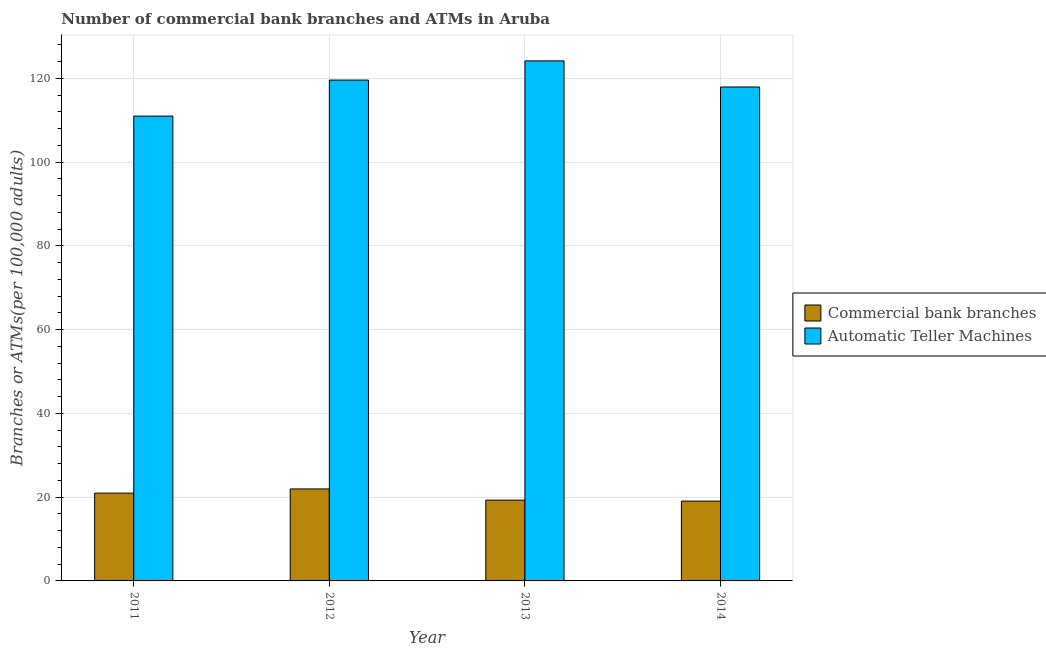How many groups of bars are there?
Keep it short and to the point. 4. How many bars are there on the 3rd tick from the right?
Offer a terse response. 2. What is the number of commercal bank branches in 2012?
Your response must be concise. 21.96. Across all years, what is the maximum number of atms?
Provide a short and direct response. 124.15. Across all years, what is the minimum number of commercal bank branches?
Provide a succinct answer. 19.06. In which year was the number of atms maximum?
Your response must be concise. 2013. In which year was the number of atms minimum?
Provide a succinct answer. 2011. What is the total number of atms in the graph?
Make the answer very short. 472.61. What is the difference between the number of atms in 2011 and that in 2013?
Make the answer very short. -13.18. What is the difference between the number of atms in 2012 and the number of commercal bank branches in 2013?
Give a very brief answer. -4.58. What is the average number of atms per year?
Your answer should be very brief. 118.15. What is the ratio of the number of commercal bank branches in 2011 to that in 2013?
Keep it short and to the point. 1.09. Is the difference between the number of atms in 2012 and 2013 greater than the difference between the number of commercal bank branches in 2012 and 2013?
Offer a very short reply. No. What is the difference between the highest and the second highest number of commercal bank branches?
Provide a succinct answer. 1. What is the difference between the highest and the lowest number of commercal bank branches?
Offer a terse response. 2.9. In how many years, is the number of commercal bank branches greater than the average number of commercal bank branches taken over all years?
Offer a very short reply. 2. What does the 2nd bar from the left in 2011 represents?
Your answer should be very brief. Automatic Teller Machines. What does the 2nd bar from the right in 2011 represents?
Give a very brief answer. Commercial bank branches. How many years are there in the graph?
Offer a terse response. 4. What is the difference between two consecutive major ticks on the Y-axis?
Ensure brevity in your answer.  20. Does the graph contain any zero values?
Provide a succinct answer. No. Does the graph contain grids?
Provide a short and direct response. Yes. Where does the legend appear in the graph?
Provide a short and direct response. Center right. How many legend labels are there?
Offer a terse response. 2. How are the legend labels stacked?
Make the answer very short. Vertical. What is the title of the graph?
Offer a terse response. Number of commercial bank branches and ATMs in Aruba. What is the label or title of the Y-axis?
Provide a succinct answer. Branches or ATMs(per 100,0 adults). What is the Branches or ATMs(per 100,000 adults) in Commercial bank branches in 2011?
Provide a short and direct response. 20.96. What is the Branches or ATMs(per 100,000 adults) of Automatic Teller Machines in 2011?
Make the answer very short. 110.97. What is the Branches or ATMs(per 100,000 adults) in Commercial bank branches in 2012?
Provide a short and direct response. 21.96. What is the Branches or ATMs(per 100,000 adults) in Automatic Teller Machines in 2012?
Your response must be concise. 119.57. What is the Branches or ATMs(per 100,000 adults) in Commercial bank branches in 2013?
Your answer should be compact. 19.29. What is the Branches or ATMs(per 100,000 adults) in Automatic Teller Machines in 2013?
Provide a succinct answer. 124.15. What is the Branches or ATMs(per 100,000 adults) in Commercial bank branches in 2014?
Give a very brief answer. 19.06. What is the Branches or ATMs(per 100,000 adults) in Automatic Teller Machines in 2014?
Offer a very short reply. 117.92. Across all years, what is the maximum Branches or ATMs(per 100,000 adults) of Commercial bank branches?
Provide a succinct answer. 21.96. Across all years, what is the maximum Branches or ATMs(per 100,000 adults) of Automatic Teller Machines?
Make the answer very short. 124.15. Across all years, what is the minimum Branches or ATMs(per 100,000 adults) of Commercial bank branches?
Your response must be concise. 19.06. Across all years, what is the minimum Branches or ATMs(per 100,000 adults) of Automatic Teller Machines?
Ensure brevity in your answer.  110.97. What is the total Branches or ATMs(per 100,000 adults) in Commercial bank branches in the graph?
Offer a terse response. 81.27. What is the total Branches or ATMs(per 100,000 adults) in Automatic Teller Machines in the graph?
Your answer should be very brief. 472.61. What is the difference between the Branches or ATMs(per 100,000 adults) of Commercial bank branches in 2011 and that in 2012?
Your answer should be compact. -1. What is the difference between the Branches or ATMs(per 100,000 adults) in Automatic Teller Machines in 2011 and that in 2012?
Provide a short and direct response. -8.6. What is the difference between the Branches or ATMs(per 100,000 adults) of Commercial bank branches in 2011 and that in 2013?
Provide a short and direct response. 1.68. What is the difference between the Branches or ATMs(per 100,000 adults) of Automatic Teller Machines in 2011 and that in 2013?
Offer a terse response. -13.18. What is the difference between the Branches or ATMs(per 100,000 adults) in Commercial bank branches in 2011 and that in 2014?
Keep it short and to the point. 1.9. What is the difference between the Branches or ATMs(per 100,000 adults) in Automatic Teller Machines in 2011 and that in 2014?
Make the answer very short. -6.95. What is the difference between the Branches or ATMs(per 100,000 adults) of Commercial bank branches in 2012 and that in 2013?
Offer a very short reply. 2.68. What is the difference between the Branches or ATMs(per 100,000 adults) of Automatic Teller Machines in 2012 and that in 2013?
Provide a succinct answer. -4.58. What is the difference between the Branches or ATMs(per 100,000 adults) of Commercial bank branches in 2012 and that in 2014?
Offer a very short reply. 2.9. What is the difference between the Branches or ATMs(per 100,000 adults) of Automatic Teller Machines in 2012 and that in 2014?
Your answer should be compact. 1.65. What is the difference between the Branches or ATMs(per 100,000 adults) of Commercial bank branches in 2013 and that in 2014?
Provide a short and direct response. 0.23. What is the difference between the Branches or ATMs(per 100,000 adults) of Automatic Teller Machines in 2013 and that in 2014?
Give a very brief answer. 6.24. What is the difference between the Branches or ATMs(per 100,000 adults) of Commercial bank branches in 2011 and the Branches or ATMs(per 100,000 adults) of Automatic Teller Machines in 2012?
Offer a very short reply. -98.61. What is the difference between the Branches or ATMs(per 100,000 adults) of Commercial bank branches in 2011 and the Branches or ATMs(per 100,000 adults) of Automatic Teller Machines in 2013?
Give a very brief answer. -103.19. What is the difference between the Branches or ATMs(per 100,000 adults) in Commercial bank branches in 2011 and the Branches or ATMs(per 100,000 adults) in Automatic Teller Machines in 2014?
Your answer should be very brief. -96.96. What is the difference between the Branches or ATMs(per 100,000 adults) of Commercial bank branches in 2012 and the Branches or ATMs(per 100,000 adults) of Automatic Teller Machines in 2013?
Your answer should be very brief. -102.19. What is the difference between the Branches or ATMs(per 100,000 adults) in Commercial bank branches in 2012 and the Branches or ATMs(per 100,000 adults) in Automatic Teller Machines in 2014?
Keep it short and to the point. -95.96. What is the difference between the Branches or ATMs(per 100,000 adults) of Commercial bank branches in 2013 and the Branches or ATMs(per 100,000 adults) of Automatic Teller Machines in 2014?
Your answer should be compact. -98.63. What is the average Branches or ATMs(per 100,000 adults) in Commercial bank branches per year?
Your response must be concise. 20.32. What is the average Branches or ATMs(per 100,000 adults) in Automatic Teller Machines per year?
Provide a short and direct response. 118.15. In the year 2011, what is the difference between the Branches or ATMs(per 100,000 adults) of Commercial bank branches and Branches or ATMs(per 100,000 adults) of Automatic Teller Machines?
Your response must be concise. -90.01. In the year 2012, what is the difference between the Branches or ATMs(per 100,000 adults) of Commercial bank branches and Branches or ATMs(per 100,000 adults) of Automatic Teller Machines?
Offer a terse response. -97.61. In the year 2013, what is the difference between the Branches or ATMs(per 100,000 adults) of Commercial bank branches and Branches or ATMs(per 100,000 adults) of Automatic Teller Machines?
Make the answer very short. -104.87. In the year 2014, what is the difference between the Branches or ATMs(per 100,000 adults) in Commercial bank branches and Branches or ATMs(per 100,000 adults) in Automatic Teller Machines?
Keep it short and to the point. -98.86. What is the ratio of the Branches or ATMs(per 100,000 adults) in Commercial bank branches in 2011 to that in 2012?
Offer a very short reply. 0.95. What is the ratio of the Branches or ATMs(per 100,000 adults) in Automatic Teller Machines in 2011 to that in 2012?
Keep it short and to the point. 0.93. What is the ratio of the Branches or ATMs(per 100,000 adults) of Commercial bank branches in 2011 to that in 2013?
Your answer should be compact. 1.09. What is the ratio of the Branches or ATMs(per 100,000 adults) of Automatic Teller Machines in 2011 to that in 2013?
Your response must be concise. 0.89. What is the ratio of the Branches or ATMs(per 100,000 adults) in Commercial bank branches in 2011 to that in 2014?
Your answer should be compact. 1.1. What is the ratio of the Branches or ATMs(per 100,000 adults) of Automatic Teller Machines in 2011 to that in 2014?
Offer a terse response. 0.94. What is the ratio of the Branches or ATMs(per 100,000 adults) of Commercial bank branches in 2012 to that in 2013?
Your answer should be very brief. 1.14. What is the ratio of the Branches or ATMs(per 100,000 adults) in Automatic Teller Machines in 2012 to that in 2013?
Provide a short and direct response. 0.96. What is the ratio of the Branches or ATMs(per 100,000 adults) in Commercial bank branches in 2012 to that in 2014?
Offer a very short reply. 1.15. What is the ratio of the Branches or ATMs(per 100,000 adults) of Automatic Teller Machines in 2012 to that in 2014?
Ensure brevity in your answer.  1.01. What is the ratio of the Branches or ATMs(per 100,000 adults) of Commercial bank branches in 2013 to that in 2014?
Provide a succinct answer. 1.01. What is the ratio of the Branches or ATMs(per 100,000 adults) in Automatic Teller Machines in 2013 to that in 2014?
Your response must be concise. 1.05. What is the difference between the highest and the second highest Branches or ATMs(per 100,000 adults) of Commercial bank branches?
Make the answer very short. 1. What is the difference between the highest and the second highest Branches or ATMs(per 100,000 adults) of Automatic Teller Machines?
Your answer should be compact. 4.58. What is the difference between the highest and the lowest Branches or ATMs(per 100,000 adults) in Commercial bank branches?
Make the answer very short. 2.9. What is the difference between the highest and the lowest Branches or ATMs(per 100,000 adults) of Automatic Teller Machines?
Your answer should be compact. 13.18. 